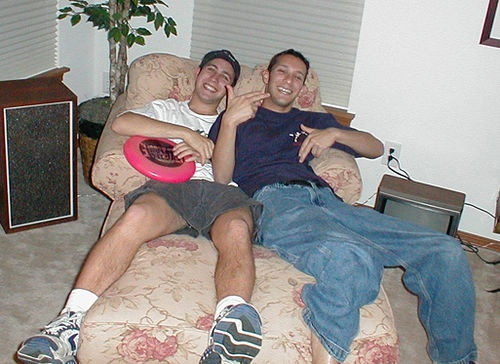Describe the objects in this image and their specific colors. I can see people in gray and navy tones, bed in gray, tan, darkgray, and lightgray tones, chair in gray, tan, darkgray, and lightgray tones, people in gray, tan, and lightgray tones, and potted plant in gray, black, darkgray, and darkgreen tones in this image. 